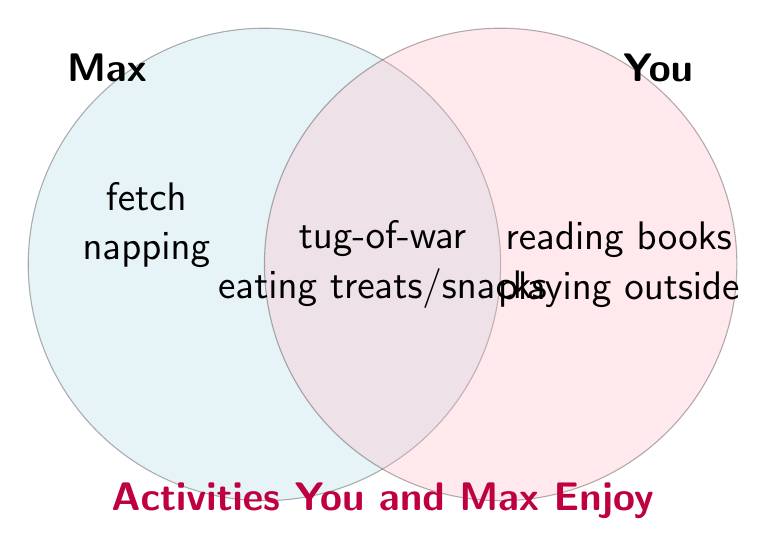Show me your answer to this math problem. To solve this problem, we need to find the intersection of the two sets: Max's activities and your activities. The intersection represents the elements that are common to both sets.

Let's define the sets:
$$M = \{\text{fetch, tug-of-war, napping, eating treats}\}$$
$$Y = \{\text{playing outside, reading books, tug-of-war, eating snacks}\}$$

To find the intersection, we look for elements that appear in both sets:

1. "tug-of-war" appears in both sets.
2. "eating treats" (for Max) and "eating snacks" (for you) can be considered the same activity.

Therefore, the intersection of the two sets is:
$$M \cap Y = \{\text{tug-of-war, eating treats/snacks}\}$$

The Venn diagram visually represents this intersection, showing the common activities in the overlapping area of the two circles.
Answer: $\{\text{tug-of-war, eating treats/snacks}\}$ 